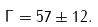<formula> <loc_0><loc_0><loc_500><loc_500>\Gamma = 5 7 \pm 1 2 .</formula> 